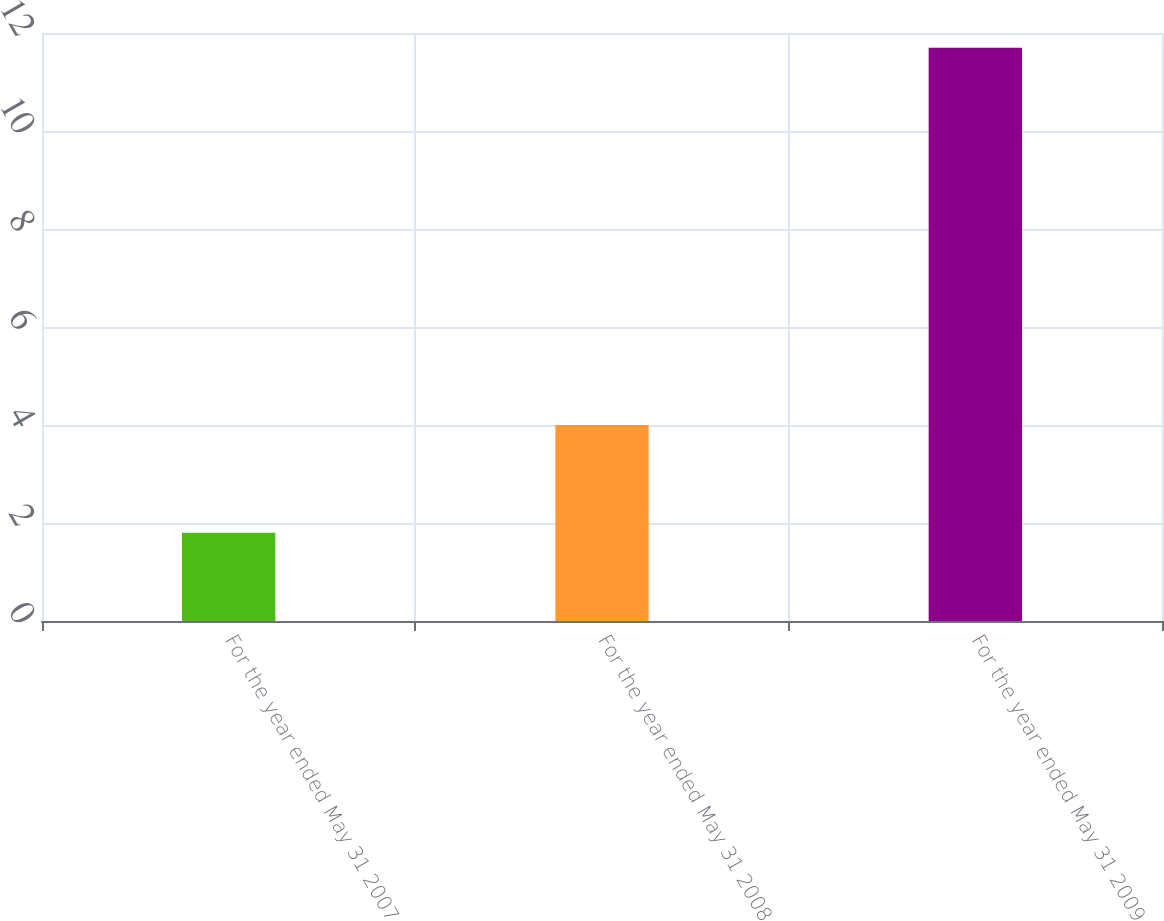<chart> <loc_0><loc_0><loc_500><loc_500><bar_chart><fcel>For the year ended May 31 2007<fcel>For the year ended May 31 2008<fcel>For the year ended May 31 2009<nl><fcel>1.8<fcel>4<fcel>11.7<nl></chart> 